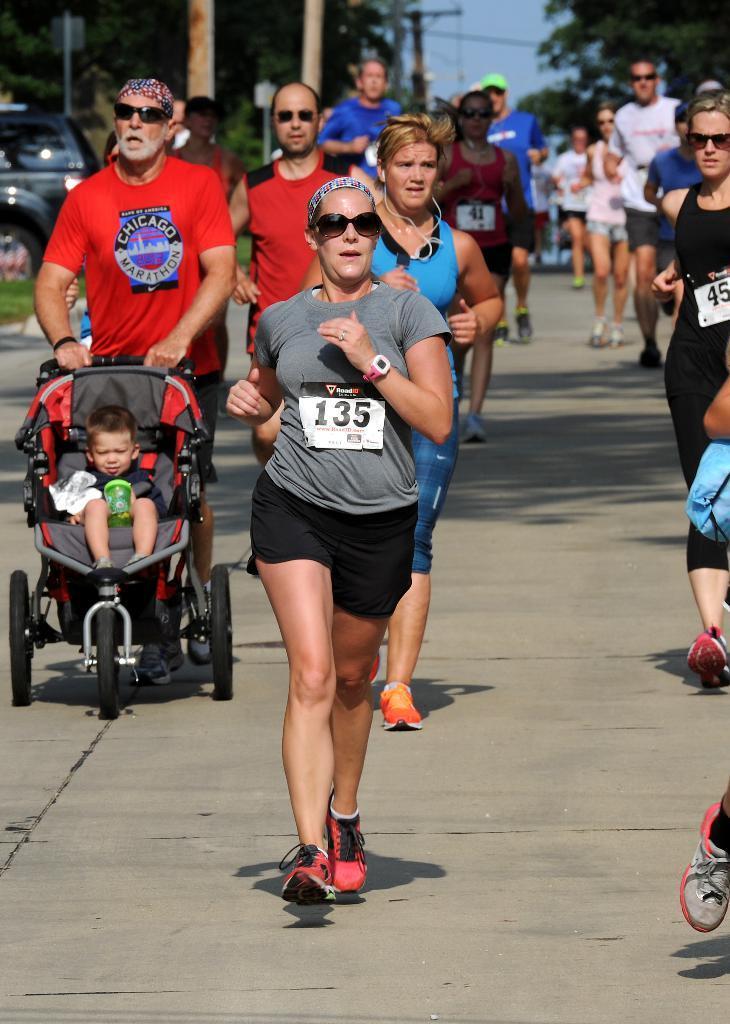How would you summarize this image in a sentence or two? In this image there are so many people running on the road, beside that there is a man holding trolly with baby, also there are so many trees, electric poles and car on the road. 